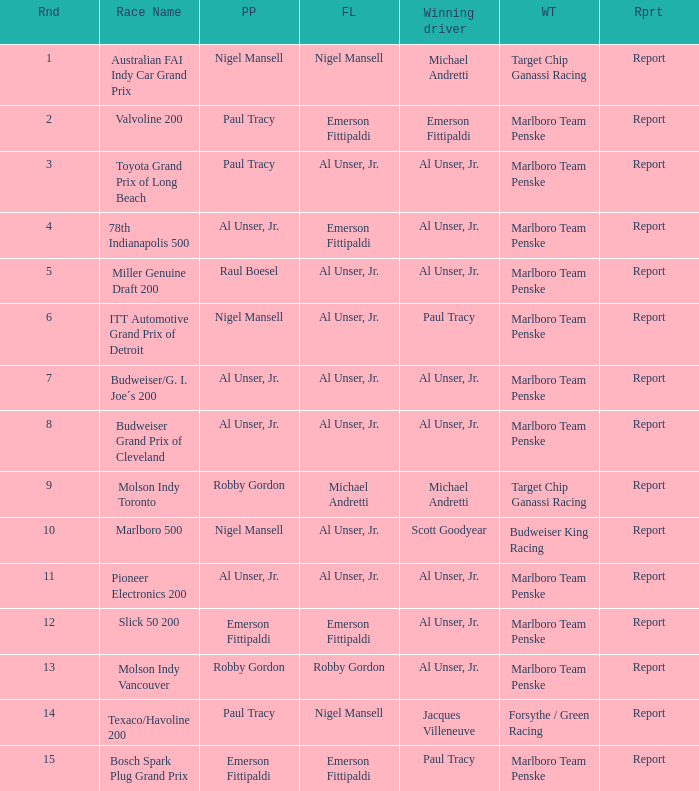Give me the full table as a dictionary. {'header': ['Rnd', 'Race Name', 'PP', 'FL', 'Winning driver', 'WT', 'Rprt'], 'rows': [['1', 'Australian FAI Indy Car Grand Prix', 'Nigel Mansell', 'Nigel Mansell', 'Michael Andretti', 'Target Chip Ganassi Racing', 'Report'], ['2', 'Valvoline 200', 'Paul Tracy', 'Emerson Fittipaldi', 'Emerson Fittipaldi', 'Marlboro Team Penske', 'Report'], ['3', 'Toyota Grand Prix of Long Beach', 'Paul Tracy', 'Al Unser, Jr.', 'Al Unser, Jr.', 'Marlboro Team Penske', 'Report'], ['4', '78th Indianapolis 500', 'Al Unser, Jr.', 'Emerson Fittipaldi', 'Al Unser, Jr.', 'Marlboro Team Penske', 'Report'], ['5', 'Miller Genuine Draft 200', 'Raul Boesel', 'Al Unser, Jr.', 'Al Unser, Jr.', 'Marlboro Team Penske', 'Report'], ['6', 'ITT Automotive Grand Prix of Detroit', 'Nigel Mansell', 'Al Unser, Jr.', 'Paul Tracy', 'Marlboro Team Penske', 'Report'], ['7', 'Budweiser/G. I. Joe´s 200', 'Al Unser, Jr.', 'Al Unser, Jr.', 'Al Unser, Jr.', 'Marlboro Team Penske', 'Report'], ['8', 'Budweiser Grand Prix of Cleveland', 'Al Unser, Jr.', 'Al Unser, Jr.', 'Al Unser, Jr.', 'Marlboro Team Penske', 'Report'], ['9', 'Molson Indy Toronto', 'Robby Gordon', 'Michael Andretti', 'Michael Andretti', 'Target Chip Ganassi Racing', 'Report'], ['10', 'Marlboro 500', 'Nigel Mansell', 'Al Unser, Jr.', 'Scott Goodyear', 'Budweiser King Racing', 'Report'], ['11', 'Pioneer Electronics 200', 'Al Unser, Jr.', 'Al Unser, Jr.', 'Al Unser, Jr.', 'Marlboro Team Penske', 'Report'], ['12', 'Slick 50 200', 'Emerson Fittipaldi', 'Emerson Fittipaldi', 'Al Unser, Jr.', 'Marlboro Team Penske', 'Report'], ['13', 'Molson Indy Vancouver', 'Robby Gordon', 'Robby Gordon', 'Al Unser, Jr.', 'Marlboro Team Penske', 'Report'], ['14', 'Texaco/Havoline 200', 'Paul Tracy', 'Nigel Mansell', 'Jacques Villeneuve', 'Forsythe / Green Racing', 'Report'], ['15', 'Bosch Spark Plug Grand Prix', 'Emerson Fittipaldi', 'Emerson Fittipaldi', 'Paul Tracy', 'Marlboro Team Penske', 'Report']]} Who did the fastest lap in the race won by Paul Tracy, with Emerson Fittipaldi at the pole position? Emerson Fittipaldi. 